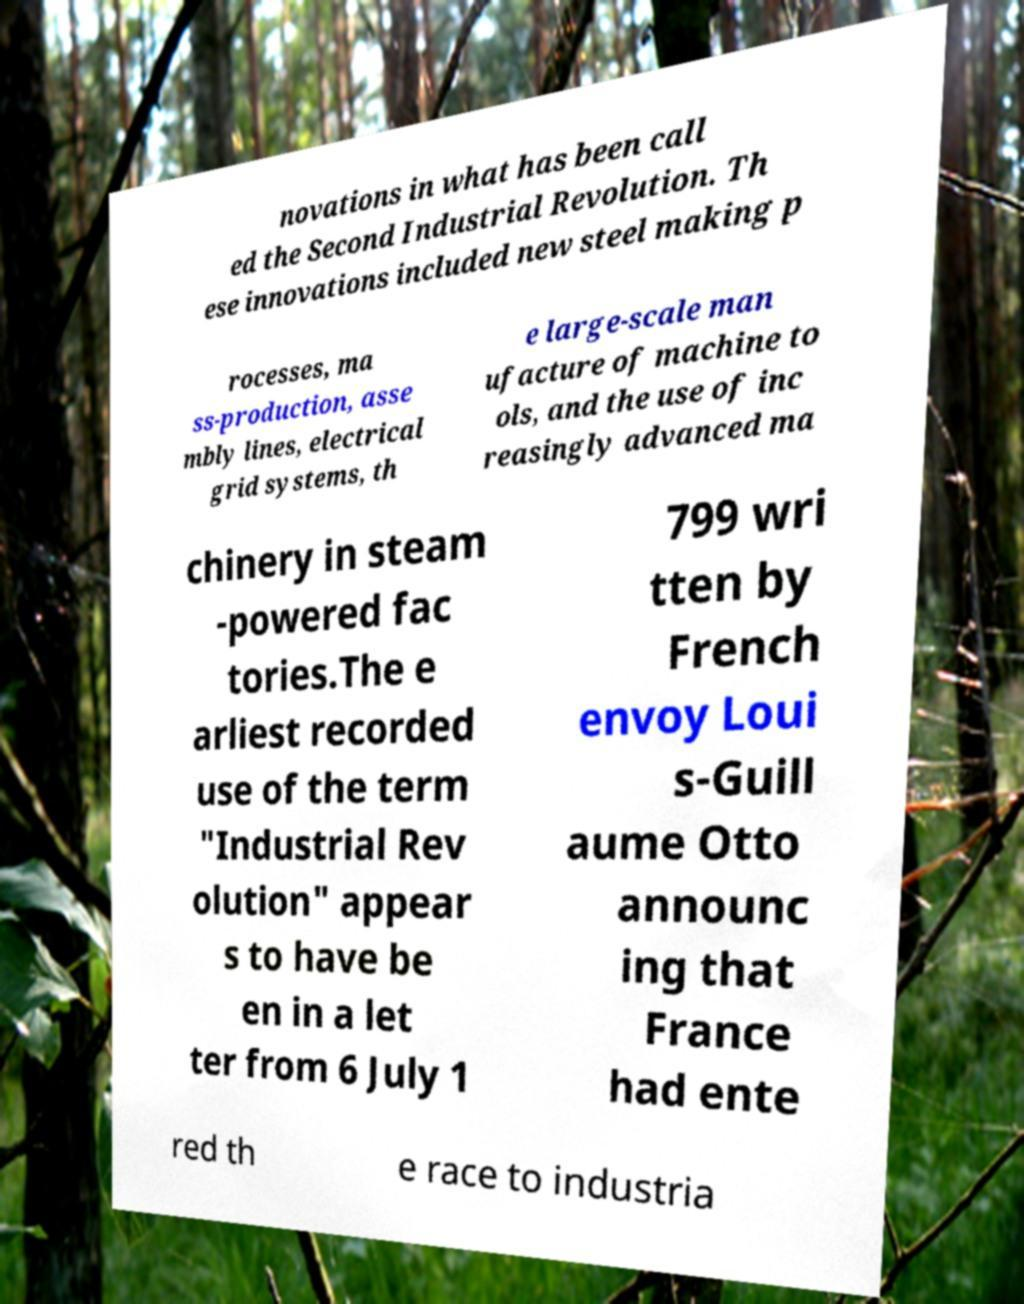Can you read and provide the text displayed in the image?This photo seems to have some interesting text. Can you extract and type it out for me? novations in what has been call ed the Second Industrial Revolution. Th ese innovations included new steel making p rocesses, ma ss-production, asse mbly lines, electrical grid systems, th e large-scale man ufacture of machine to ols, and the use of inc reasingly advanced ma chinery in steam -powered fac tories.The e arliest recorded use of the term "Industrial Rev olution" appear s to have be en in a let ter from 6 July 1 799 wri tten by French envoy Loui s-Guill aume Otto announc ing that France had ente red th e race to industria 